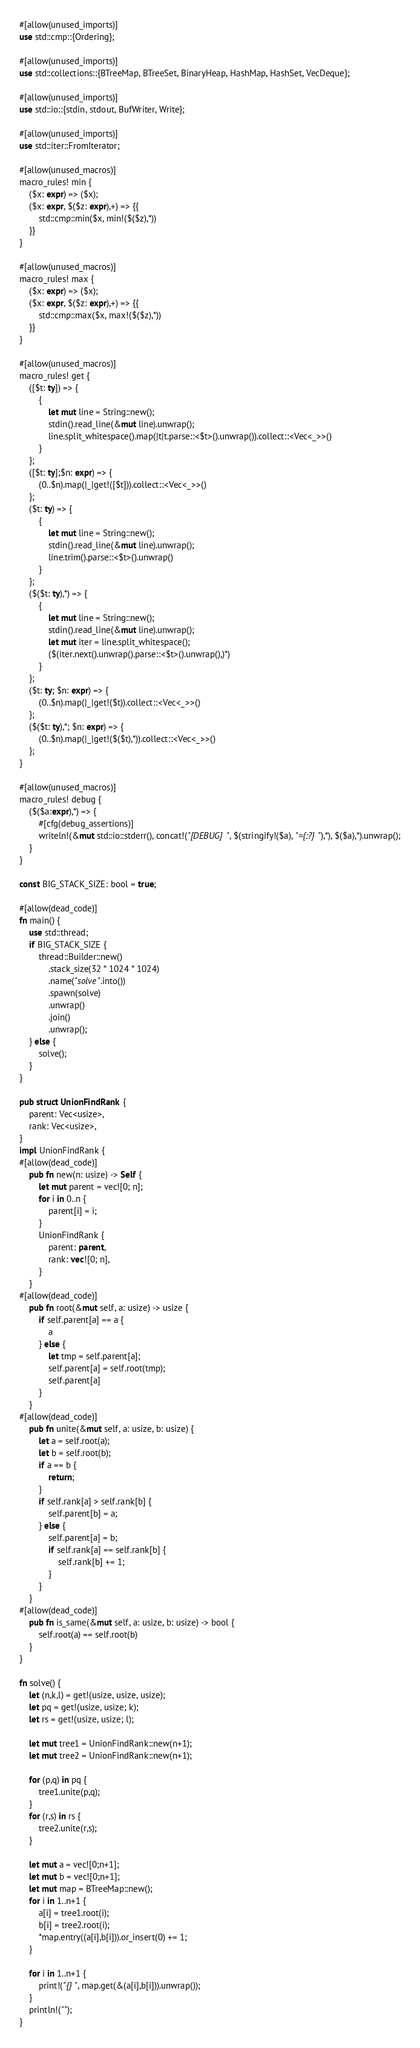Convert code to text. <code><loc_0><loc_0><loc_500><loc_500><_Rust_>#[allow(unused_imports)]
use std::cmp::{Ordering};

#[allow(unused_imports)]
use std::collections::{BTreeMap, BTreeSet, BinaryHeap, HashMap, HashSet, VecDeque};

#[allow(unused_imports)]
use std::io::{stdin, stdout, BufWriter, Write};

#[allow(unused_imports)]
use std::iter::FromIterator;

#[allow(unused_macros)]
macro_rules! min {
    ($x: expr) => ($x);
    ($x: expr, $($z: expr),+) => {{
        std::cmp::min($x, min!($($z),*))
    }}
}

#[allow(unused_macros)]
macro_rules! max {
    ($x: expr) => ($x);
    ($x: expr, $($z: expr),+) => {{
        std::cmp::max($x, max!($($z),*))
    }}
}

#[allow(unused_macros)]
macro_rules! get { 
    ([$t: ty]) => { 
        { 
            let mut line = String::new(); 
            stdin().read_line(&mut line).unwrap(); 
            line.split_whitespace().map(|t|t.parse::<$t>().unwrap()).collect::<Vec<_>>()
        }
    };
    ([$t: ty];$n: expr) => {
        (0..$n).map(|_|get!([$t])).collect::<Vec<_>>()
    };
    ($t: ty) => {
        {
            let mut line = String::new();
            stdin().read_line(&mut line).unwrap();
            line.trim().parse::<$t>().unwrap()
        }
    };
    ($($t: ty),*) => {
        { 
            let mut line = String::new();
            stdin().read_line(&mut line).unwrap();
            let mut iter = line.split_whitespace();
            ($(iter.next().unwrap().parse::<$t>().unwrap(),)*)
        }
    };
    ($t: ty; $n: expr) => {
        (0..$n).map(|_|get!($t)).collect::<Vec<_>>()
    };
    ($($t: ty),*; $n: expr) => {
        (0..$n).map(|_|get!($($t),*)).collect::<Vec<_>>()
    };
}

#[allow(unused_macros)]
macro_rules! debug {
    ($($a:expr),*) => {
        #[cfg(debug_assertions)]
        writeln!(&mut std::io::stderr(), concat!("[DEBUG] ", $(stringify!($a), "={:?} "),*), $($a),*).unwrap();
    }
}

const BIG_STACK_SIZE: bool = true;

#[allow(dead_code)]
fn main() {
    use std::thread;
    if BIG_STACK_SIZE {
        thread::Builder::new()
            .stack_size(32 * 1024 * 1024)
            .name("solve".into())
            .spawn(solve)
            .unwrap()
            .join()
            .unwrap();
    } else {
        solve();
    }
}

pub struct UnionFindRank {
    parent: Vec<usize>,
    rank: Vec<usize>,
}
impl UnionFindRank {
#[allow(dead_code)]
    pub fn new(n: usize) -> Self {
        let mut parent = vec![0; n];
        for i in 0..n {
            parent[i] = i;
        }
        UnionFindRank {
            parent: parent,
            rank: vec![0; n],
        }
    }
#[allow(dead_code)]
    pub fn root(&mut self, a: usize) -> usize {
        if self.parent[a] == a {
            a
        } else {
            let tmp = self.parent[a];
            self.parent[a] = self.root(tmp);
            self.parent[a]
        }
    }
#[allow(dead_code)]
    pub fn unite(&mut self, a: usize, b: usize) {
        let a = self.root(a);
        let b = self.root(b);
        if a == b {
            return;
        }
        if self.rank[a] > self.rank[b] {
            self.parent[b] = a;
        } else {
            self.parent[a] = b;
            if self.rank[a] == self.rank[b] {
                self.rank[b] += 1;
            }
        }
    }
#[allow(dead_code)]
    pub fn is_same(&mut self, a: usize, b: usize) -> bool {
        self.root(a) == self.root(b)
    }
}

fn solve() {
    let (n,k,l) = get!(usize, usize, usize);
    let pq = get!(usize, usize; k);
    let rs = get!(usize, usize; l);

    let mut tree1 = UnionFindRank::new(n+1);
    let mut tree2 = UnionFindRank::new(n+1);

    for (p,q) in pq {
        tree1.unite(p,q);
    }
    for (r,s) in rs {
        tree2.unite(r,s);
    }

    let mut a = vec![0;n+1];
    let mut b = vec![0;n+1];
    let mut map = BTreeMap::new();
    for i in 1..n+1 {
        a[i] = tree1.root(i);
        b[i] = tree2.root(i);
        *map.entry((a[i],b[i])).or_insert(0) += 1;
    }

    for i in 1..n+1 {
        print!("{} ", map.get(&(a[i],b[i])).unwrap());
    }
    println!("");
}
</code> 